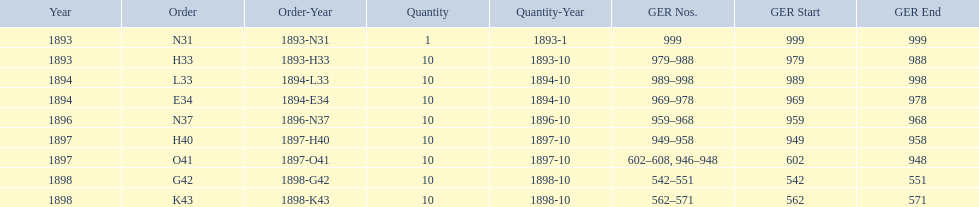When was g42, 1898 or 1894? 1898. 